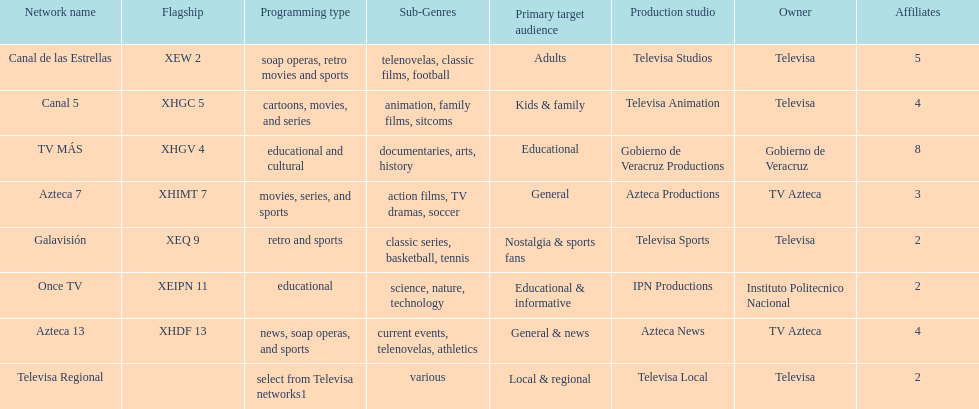Whose networks are the most numerous among owners? Televisa. 